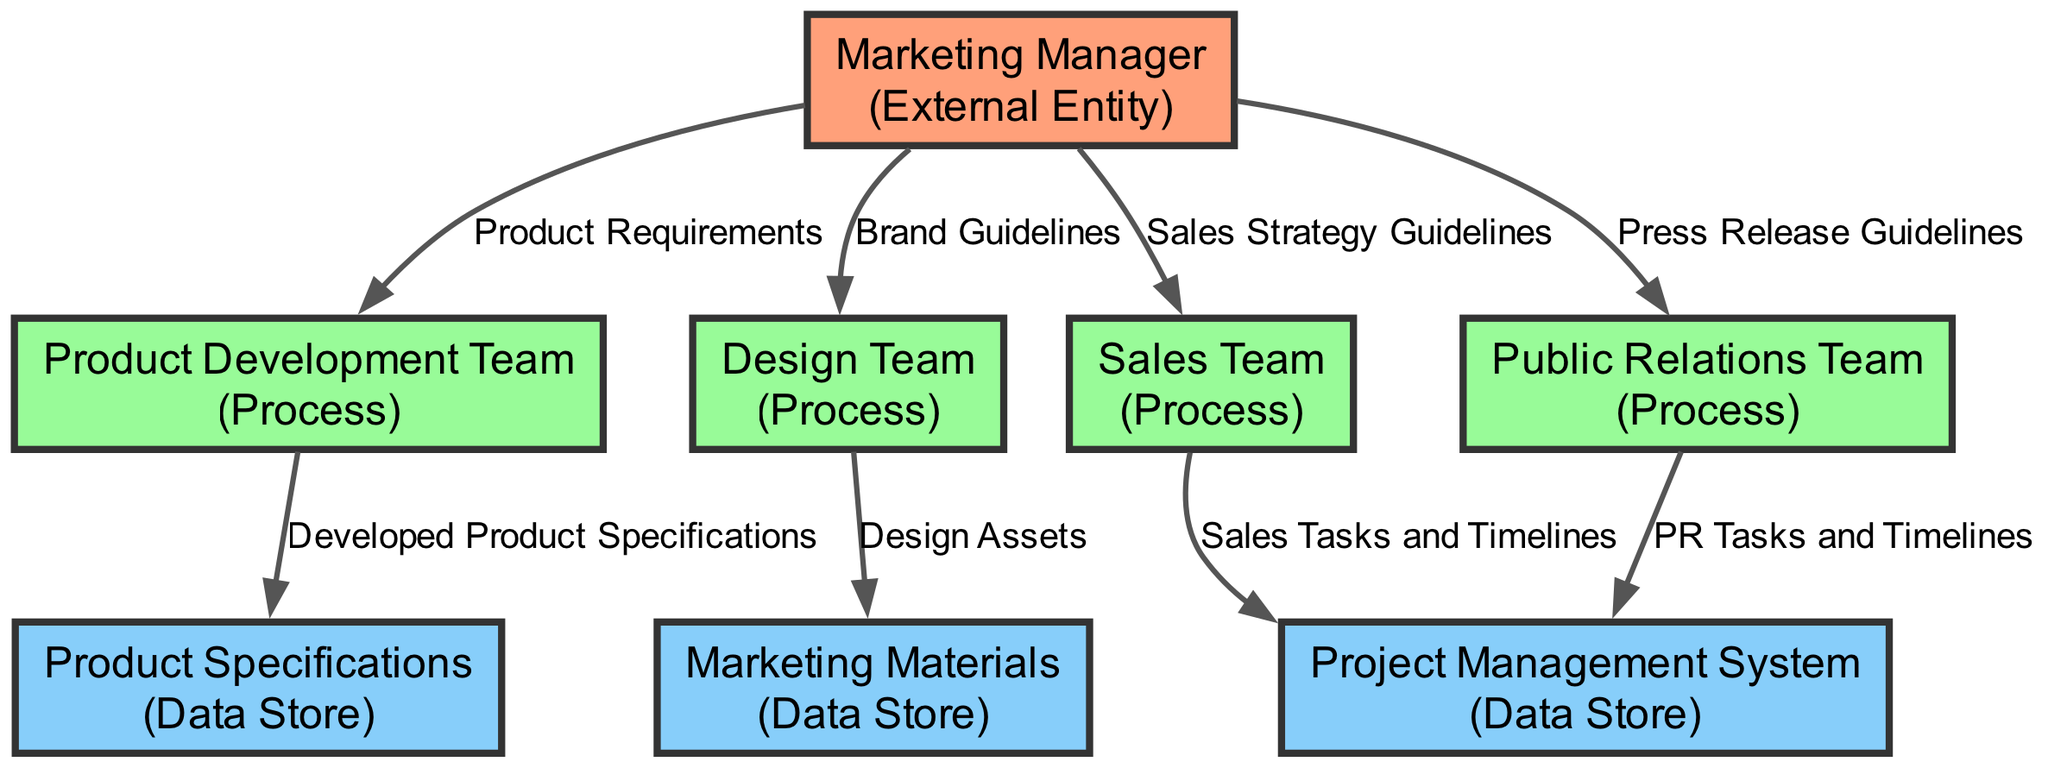What is the role of the Marketing Manager? The Marketing Manager is identified as an External Entity in the diagram, overseeing the entire product launch and ensuring alignment with brand guidelines.
Answer: Oversees the entire product launch How many processes are in the diagram? The processes identified in the diagram include the Product Development Team, Design Team, Sales Team, and Public Relations Team, totaling four distinct processes.
Answer: Four What data does the Marketing Manager provide to the Product Development Team? According to the diagram, the Marketing Manager provides "Product Requirements" to the Product Development Team, guiding them on what is needed for development.
Answer: Product Requirements Which team is responsible for creating design assets? The Design Team is responsible for creating design assets, as indicated in the diagram, which includes logos, packaging, and promotional materials.
Answer: Design Team What data flows from the Sales Team to the Project Management System? The data that flows from the Sales Team to the Project Management System is labeled "Sales Tasks and Timelines," documenting tasks related to sales activities.
Answer: Sales Tasks and Timelines If the Marketing Manager changes the Brand Guidelines, which team is affected directly? The Design Team is directly affected because they receive the Brand Guidelines from the Marketing Manager, which informs their design work.
Answer: Design Team Which data store contains promotional assets? The data store named "Marketing Materials" contains promotional assets, product information sheets, and brand guidelines as specified in the diagram.
Answer: Marketing Materials How many data flows originate from the Marketing Manager? The diagram indicates that there are four data flows originating from the Marketing Manager, as they interact with the Product Development Team, Design Team, Sales Team, and Public Relations Team.
Answer: Four What is the purpose of the Project Management System in the workflow? The Project Management System serves as a data repository that tracks project timelines, tasks, and deliverables related to sales and public relations activities as illustrated in the diagram.
Answer: Tracks project timelines 